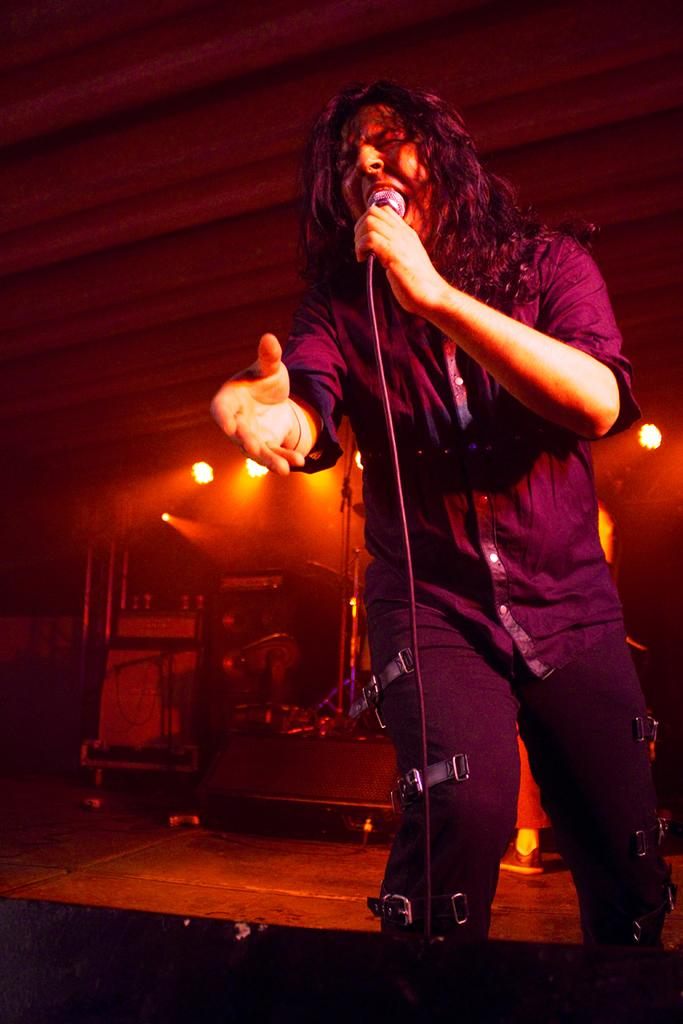What is the person in the image holding? The person is holding a mic in the image. What is the person doing with the mic? The person is singing while holding the mic. What can be seen on top in the image? There are lights on top in the image. What is visible in the background of the image? There are stands, a loudspeaker, and other objects in the background of the image. What time of day is it in the image, considering the presence of trucks? There are no trucks present in the image, so it is not possible to determine the time of day based on their absence. 